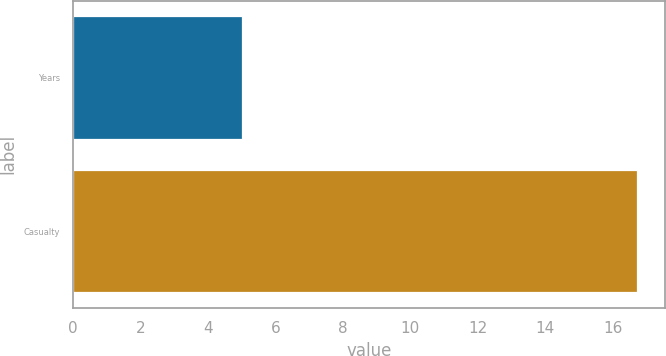Convert chart. <chart><loc_0><loc_0><loc_500><loc_500><bar_chart><fcel>Years<fcel>Casualty<nl><fcel>5<fcel>16.7<nl></chart> 